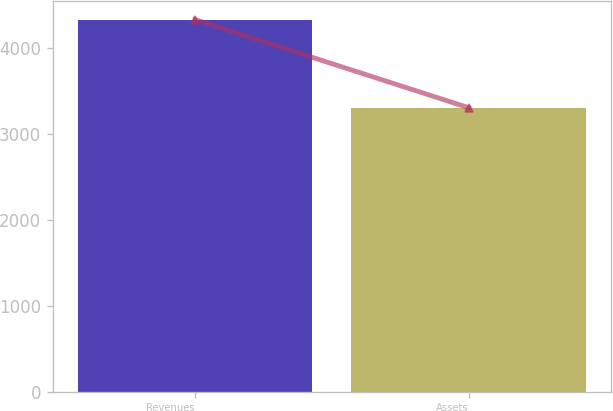<chart> <loc_0><loc_0><loc_500><loc_500><bar_chart><fcel>Revenues<fcel>Assets<nl><fcel>4329.9<fcel>3304.7<nl></chart> 